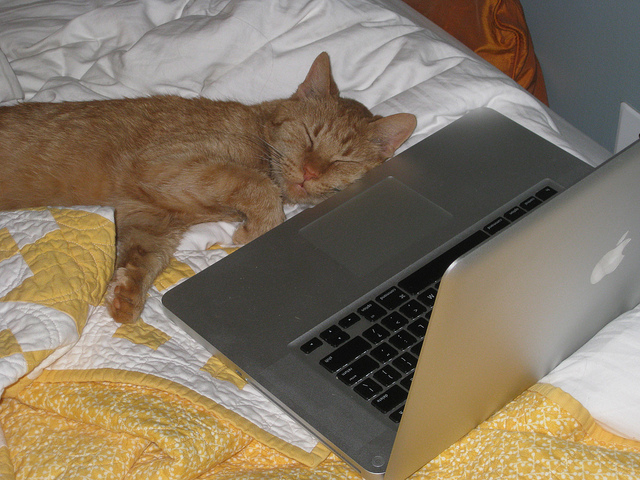<image>What black item is lying beside the computer? I am not sure what the black item lying beside the computer is. It could either be a cat or a laptop or there might be nothing. What black item is lying beside the computer? I don't know what black item is lying beside the computer. It can be a cat or nothing. 